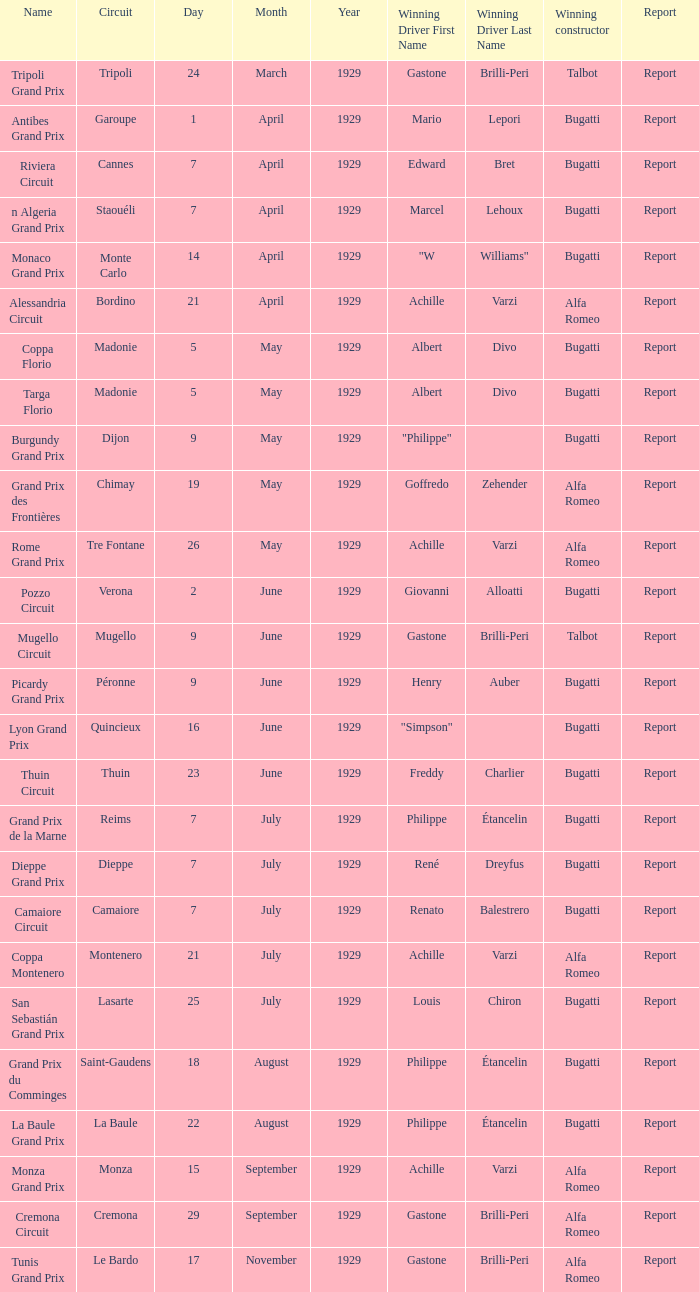What Date has a Name of thuin circuit? 23 June. 